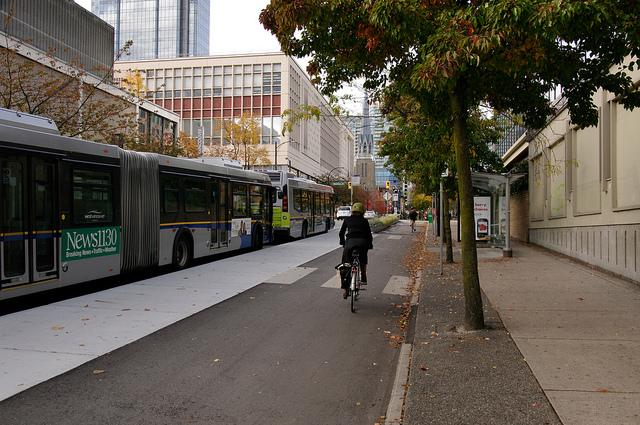What type of lane is shown? bike lane 